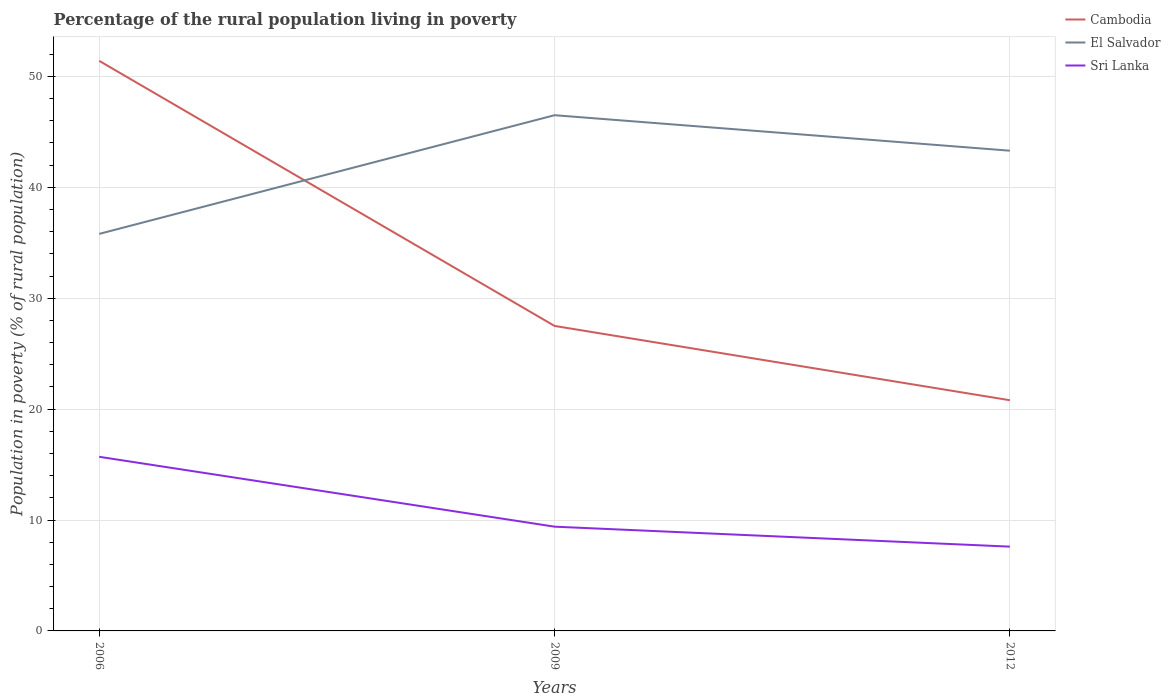How many different coloured lines are there?
Give a very brief answer. 3. Is the number of lines equal to the number of legend labels?
Make the answer very short. Yes. Across all years, what is the maximum percentage of the rural population living in poverty in Cambodia?
Your response must be concise. 20.8. In which year was the percentage of the rural population living in poverty in Sri Lanka maximum?
Ensure brevity in your answer.  2012. What is the total percentage of the rural population living in poverty in El Salvador in the graph?
Offer a very short reply. 3.2. What is the difference between the highest and the second highest percentage of the rural population living in poverty in El Salvador?
Provide a short and direct response. 10.7. How many lines are there?
Your answer should be compact. 3. What is the difference between two consecutive major ticks on the Y-axis?
Give a very brief answer. 10. Where does the legend appear in the graph?
Offer a terse response. Top right. How many legend labels are there?
Provide a succinct answer. 3. How are the legend labels stacked?
Your answer should be compact. Vertical. What is the title of the graph?
Your answer should be very brief. Percentage of the rural population living in poverty. What is the label or title of the X-axis?
Offer a very short reply. Years. What is the label or title of the Y-axis?
Keep it short and to the point. Population in poverty (% of rural population). What is the Population in poverty (% of rural population) of Cambodia in 2006?
Your answer should be very brief. 51.4. What is the Population in poverty (% of rural population) of El Salvador in 2006?
Provide a succinct answer. 35.8. What is the Population in poverty (% of rural population) of Cambodia in 2009?
Provide a succinct answer. 27.5. What is the Population in poverty (% of rural population) of El Salvador in 2009?
Your response must be concise. 46.5. What is the Population in poverty (% of rural population) in Sri Lanka in 2009?
Offer a terse response. 9.4. What is the Population in poverty (% of rural population) in Cambodia in 2012?
Offer a terse response. 20.8. What is the Population in poverty (% of rural population) in El Salvador in 2012?
Ensure brevity in your answer.  43.3. What is the Population in poverty (% of rural population) of Sri Lanka in 2012?
Give a very brief answer. 7.6. Across all years, what is the maximum Population in poverty (% of rural population) of Cambodia?
Offer a very short reply. 51.4. Across all years, what is the maximum Population in poverty (% of rural population) in El Salvador?
Your answer should be very brief. 46.5. Across all years, what is the minimum Population in poverty (% of rural population) of Cambodia?
Your response must be concise. 20.8. Across all years, what is the minimum Population in poverty (% of rural population) in El Salvador?
Your answer should be very brief. 35.8. What is the total Population in poverty (% of rural population) of Cambodia in the graph?
Give a very brief answer. 99.7. What is the total Population in poverty (% of rural population) in El Salvador in the graph?
Make the answer very short. 125.6. What is the total Population in poverty (% of rural population) of Sri Lanka in the graph?
Your response must be concise. 32.7. What is the difference between the Population in poverty (% of rural population) in Cambodia in 2006 and that in 2009?
Ensure brevity in your answer.  23.9. What is the difference between the Population in poverty (% of rural population) in El Salvador in 2006 and that in 2009?
Provide a succinct answer. -10.7. What is the difference between the Population in poverty (% of rural population) of Sri Lanka in 2006 and that in 2009?
Offer a terse response. 6.3. What is the difference between the Population in poverty (% of rural population) in Cambodia in 2006 and that in 2012?
Provide a short and direct response. 30.6. What is the difference between the Population in poverty (% of rural population) of Sri Lanka in 2006 and that in 2012?
Your answer should be very brief. 8.1. What is the difference between the Population in poverty (% of rural population) in Cambodia in 2009 and that in 2012?
Make the answer very short. 6.7. What is the difference between the Population in poverty (% of rural population) of Sri Lanka in 2009 and that in 2012?
Your answer should be compact. 1.8. What is the difference between the Population in poverty (% of rural population) in Cambodia in 2006 and the Population in poverty (% of rural population) in El Salvador in 2009?
Offer a very short reply. 4.9. What is the difference between the Population in poverty (% of rural population) of Cambodia in 2006 and the Population in poverty (% of rural population) of Sri Lanka in 2009?
Provide a short and direct response. 42. What is the difference between the Population in poverty (% of rural population) in El Salvador in 2006 and the Population in poverty (% of rural population) in Sri Lanka in 2009?
Offer a terse response. 26.4. What is the difference between the Population in poverty (% of rural population) in Cambodia in 2006 and the Population in poverty (% of rural population) in Sri Lanka in 2012?
Your answer should be very brief. 43.8. What is the difference between the Population in poverty (% of rural population) in El Salvador in 2006 and the Population in poverty (% of rural population) in Sri Lanka in 2012?
Offer a terse response. 28.2. What is the difference between the Population in poverty (% of rural population) of Cambodia in 2009 and the Population in poverty (% of rural population) of El Salvador in 2012?
Make the answer very short. -15.8. What is the difference between the Population in poverty (% of rural population) of Cambodia in 2009 and the Population in poverty (% of rural population) of Sri Lanka in 2012?
Your answer should be compact. 19.9. What is the difference between the Population in poverty (% of rural population) of El Salvador in 2009 and the Population in poverty (% of rural population) of Sri Lanka in 2012?
Offer a very short reply. 38.9. What is the average Population in poverty (% of rural population) in Cambodia per year?
Provide a short and direct response. 33.23. What is the average Population in poverty (% of rural population) in El Salvador per year?
Provide a short and direct response. 41.87. In the year 2006, what is the difference between the Population in poverty (% of rural population) of Cambodia and Population in poverty (% of rural population) of Sri Lanka?
Make the answer very short. 35.7. In the year 2006, what is the difference between the Population in poverty (% of rural population) of El Salvador and Population in poverty (% of rural population) of Sri Lanka?
Offer a terse response. 20.1. In the year 2009, what is the difference between the Population in poverty (% of rural population) in Cambodia and Population in poverty (% of rural population) in Sri Lanka?
Your answer should be very brief. 18.1. In the year 2009, what is the difference between the Population in poverty (% of rural population) in El Salvador and Population in poverty (% of rural population) in Sri Lanka?
Provide a succinct answer. 37.1. In the year 2012, what is the difference between the Population in poverty (% of rural population) of Cambodia and Population in poverty (% of rural population) of El Salvador?
Keep it short and to the point. -22.5. In the year 2012, what is the difference between the Population in poverty (% of rural population) of El Salvador and Population in poverty (% of rural population) of Sri Lanka?
Make the answer very short. 35.7. What is the ratio of the Population in poverty (% of rural population) in Cambodia in 2006 to that in 2009?
Provide a succinct answer. 1.87. What is the ratio of the Population in poverty (% of rural population) of El Salvador in 2006 to that in 2009?
Provide a short and direct response. 0.77. What is the ratio of the Population in poverty (% of rural population) of Sri Lanka in 2006 to that in 2009?
Provide a short and direct response. 1.67. What is the ratio of the Population in poverty (% of rural population) in Cambodia in 2006 to that in 2012?
Provide a succinct answer. 2.47. What is the ratio of the Population in poverty (% of rural population) in El Salvador in 2006 to that in 2012?
Provide a succinct answer. 0.83. What is the ratio of the Population in poverty (% of rural population) in Sri Lanka in 2006 to that in 2012?
Your response must be concise. 2.07. What is the ratio of the Population in poverty (% of rural population) of Cambodia in 2009 to that in 2012?
Make the answer very short. 1.32. What is the ratio of the Population in poverty (% of rural population) in El Salvador in 2009 to that in 2012?
Ensure brevity in your answer.  1.07. What is the ratio of the Population in poverty (% of rural population) of Sri Lanka in 2009 to that in 2012?
Keep it short and to the point. 1.24. What is the difference between the highest and the second highest Population in poverty (% of rural population) in Cambodia?
Your answer should be very brief. 23.9. What is the difference between the highest and the lowest Population in poverty (% of rural population) in Cambodia?
Your answer should be compact. 30.6. What is the difference between the highest and the lowest Population in poverty (% of rural population) of Sri Lanka?
Provide a succinct answer. 8.1. 